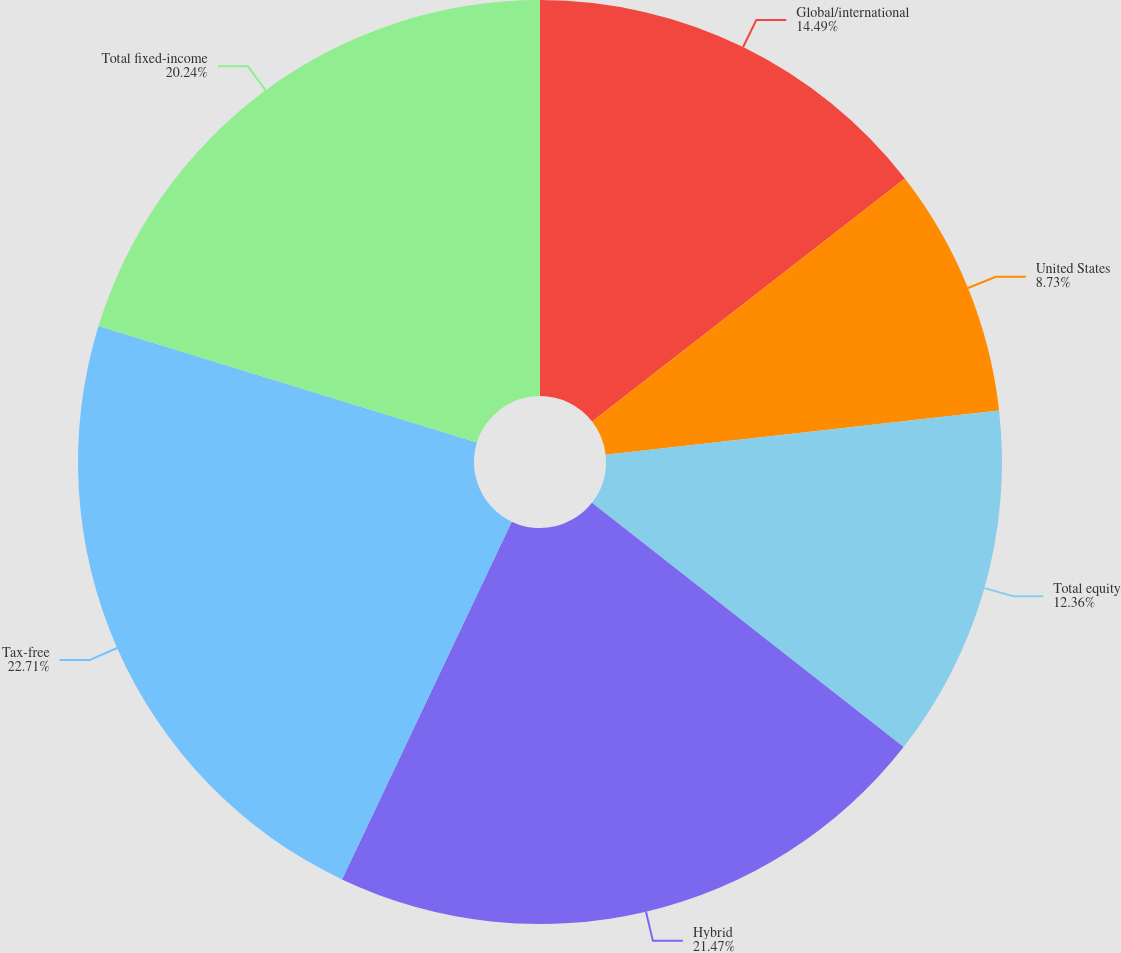<chart> <loc_0><loc_0><loc_500><loc_500><pie_chart><fcel>Global/international<fcel>United States<fcel>Total equity<fcel>Hybrid<fcel>Tax-free<fcel>Total fixed-income<nl><fcel>14.49%<fcel>8.73%<fcel>12.36%<fcel>21.47%<fcel>22.71%<fcel>20.24%<nl></chart> 